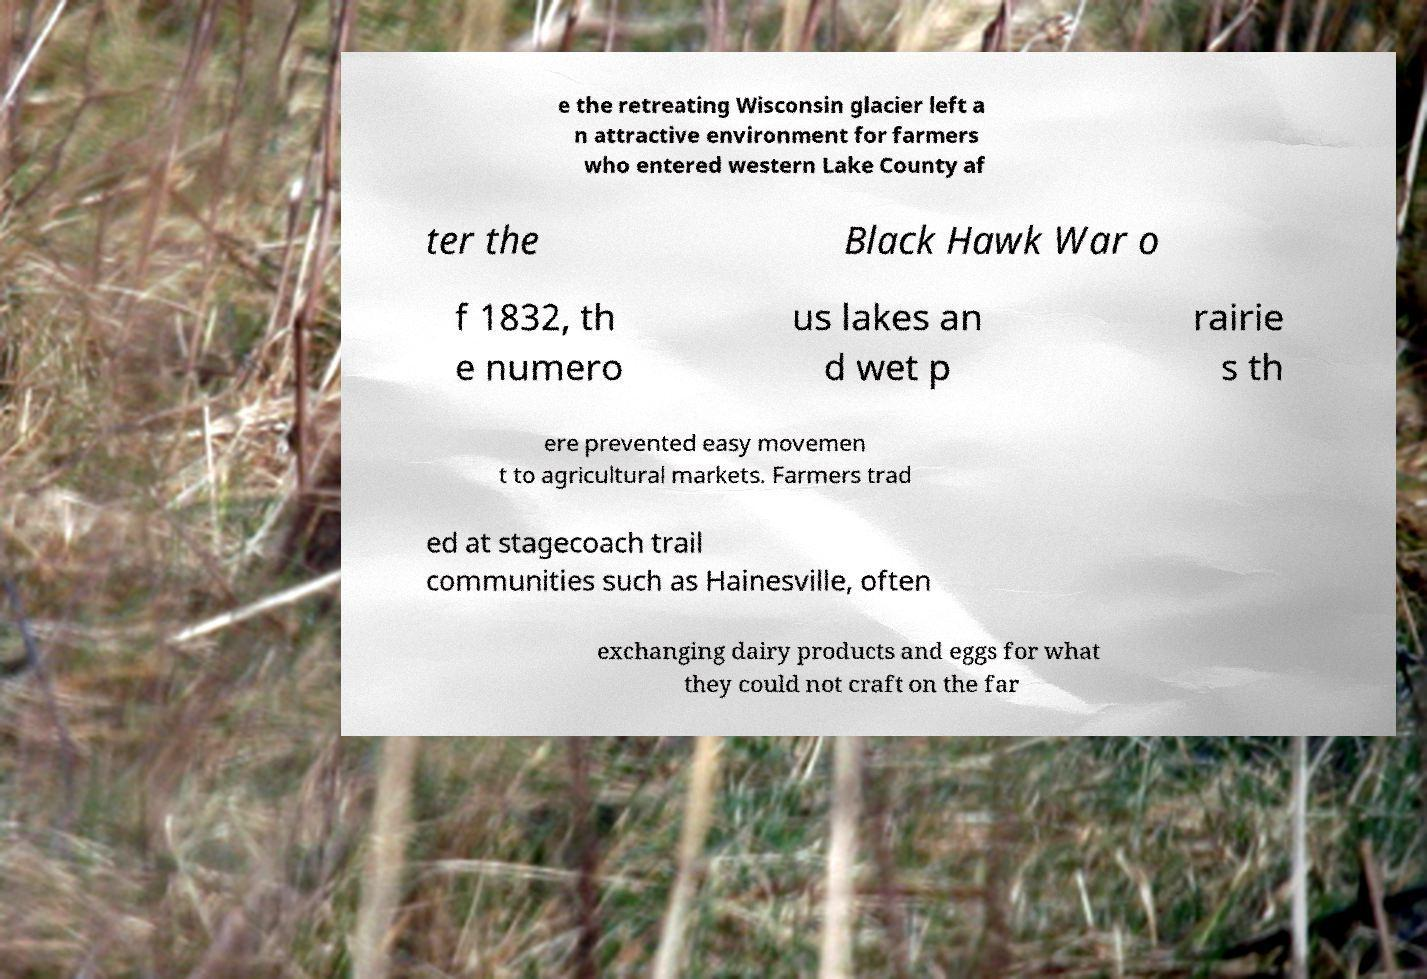I need the written content from this picture converted into text. Can you do that? e the retreating Wisconsin glacier left a n attractive environment for farmers who entered western Lake County af ter the Black Hawk War o f 1832, th e numero us lakes an d wet p rairie s th ere prevented easy movemen t to agricultural markets. Farmers trad ed at stagecoach trail communities such as Hainesville, often exchanging dairy products and eggs for what they could not craft on the far 